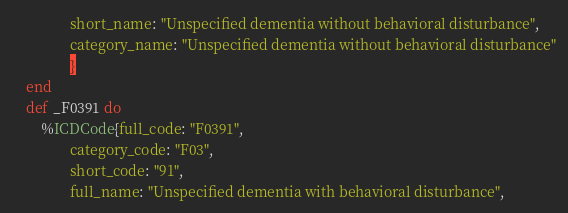Convert code to text. <code><loc_0><loc_0><loc_500><loc_500><_Elixir_>        		short_name: "Unspecified dementia without behavioral disturbance",
        		category_name: "Unspecified dementia without behavioral disturbance"
        		}
	end
	def _F0391 do 
		%ICDCode{full_code: "F0391",
        		category_code: "F03",
        		short_code: "91",
        		full_name: "Unspecified dementia with behavioral disturbance",</code> 